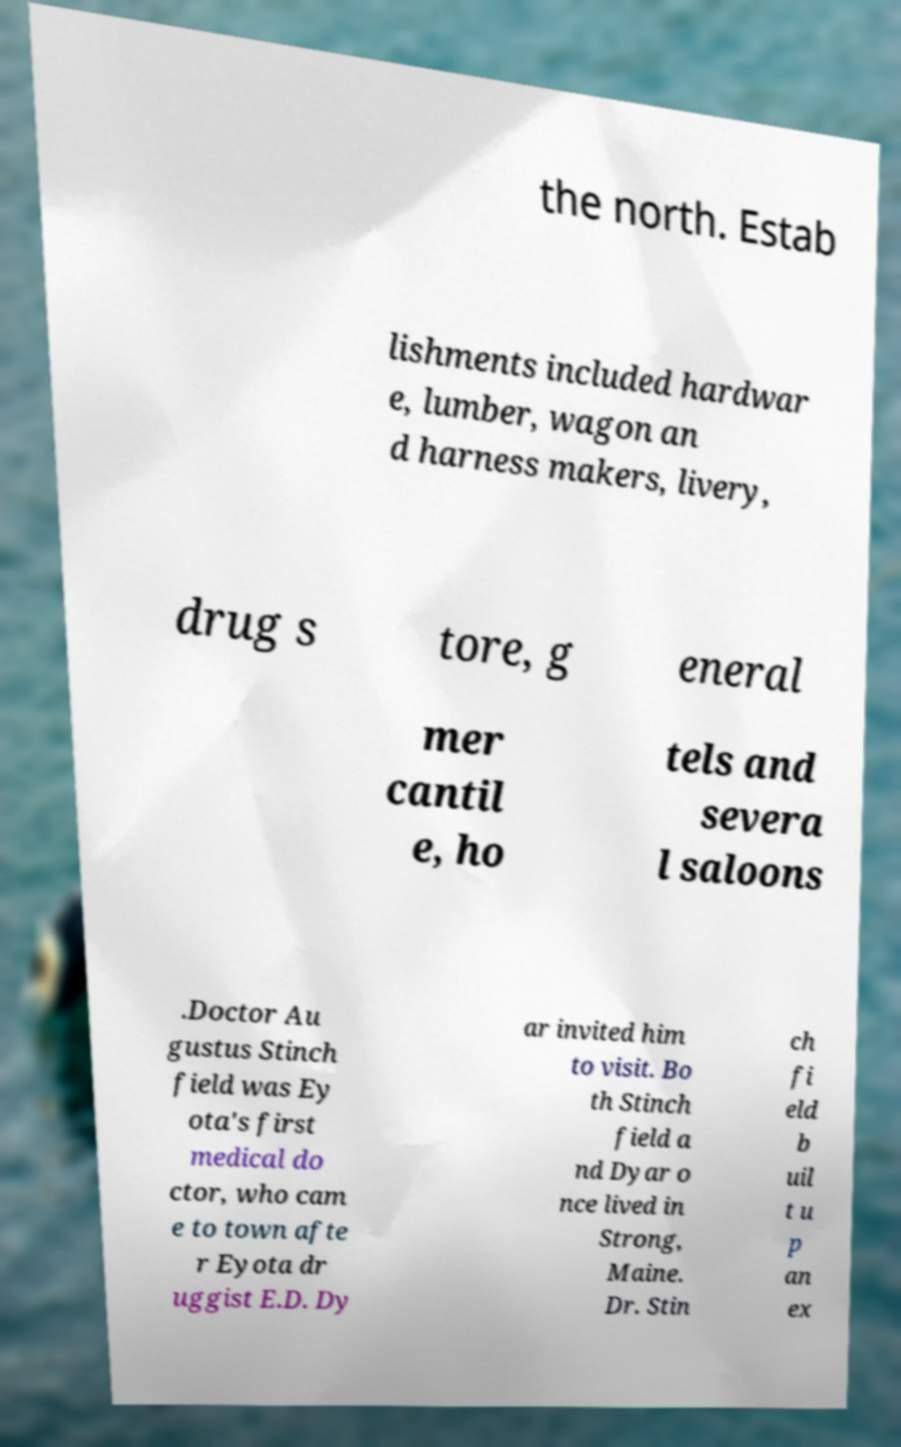For documentation purposes, I need the text within this image transcribed. Could you provide that? the north. Estab lishments included hardwar e, lumber, wagon an d harness makers, livery, drug s tore, g eneral mer cantil e, ho tels and severa l saloons .Doctor Au gustus Stinch field was Ey ota's first medical do ctor, who cam e to town afte r Eyota dr uggist E.D. Dy ar invited him to visit. Bo th Stinch field a nd Dyar o nce lived in Strong, Maine. Dr. Stin ch fi eld b uil t u p an ex 